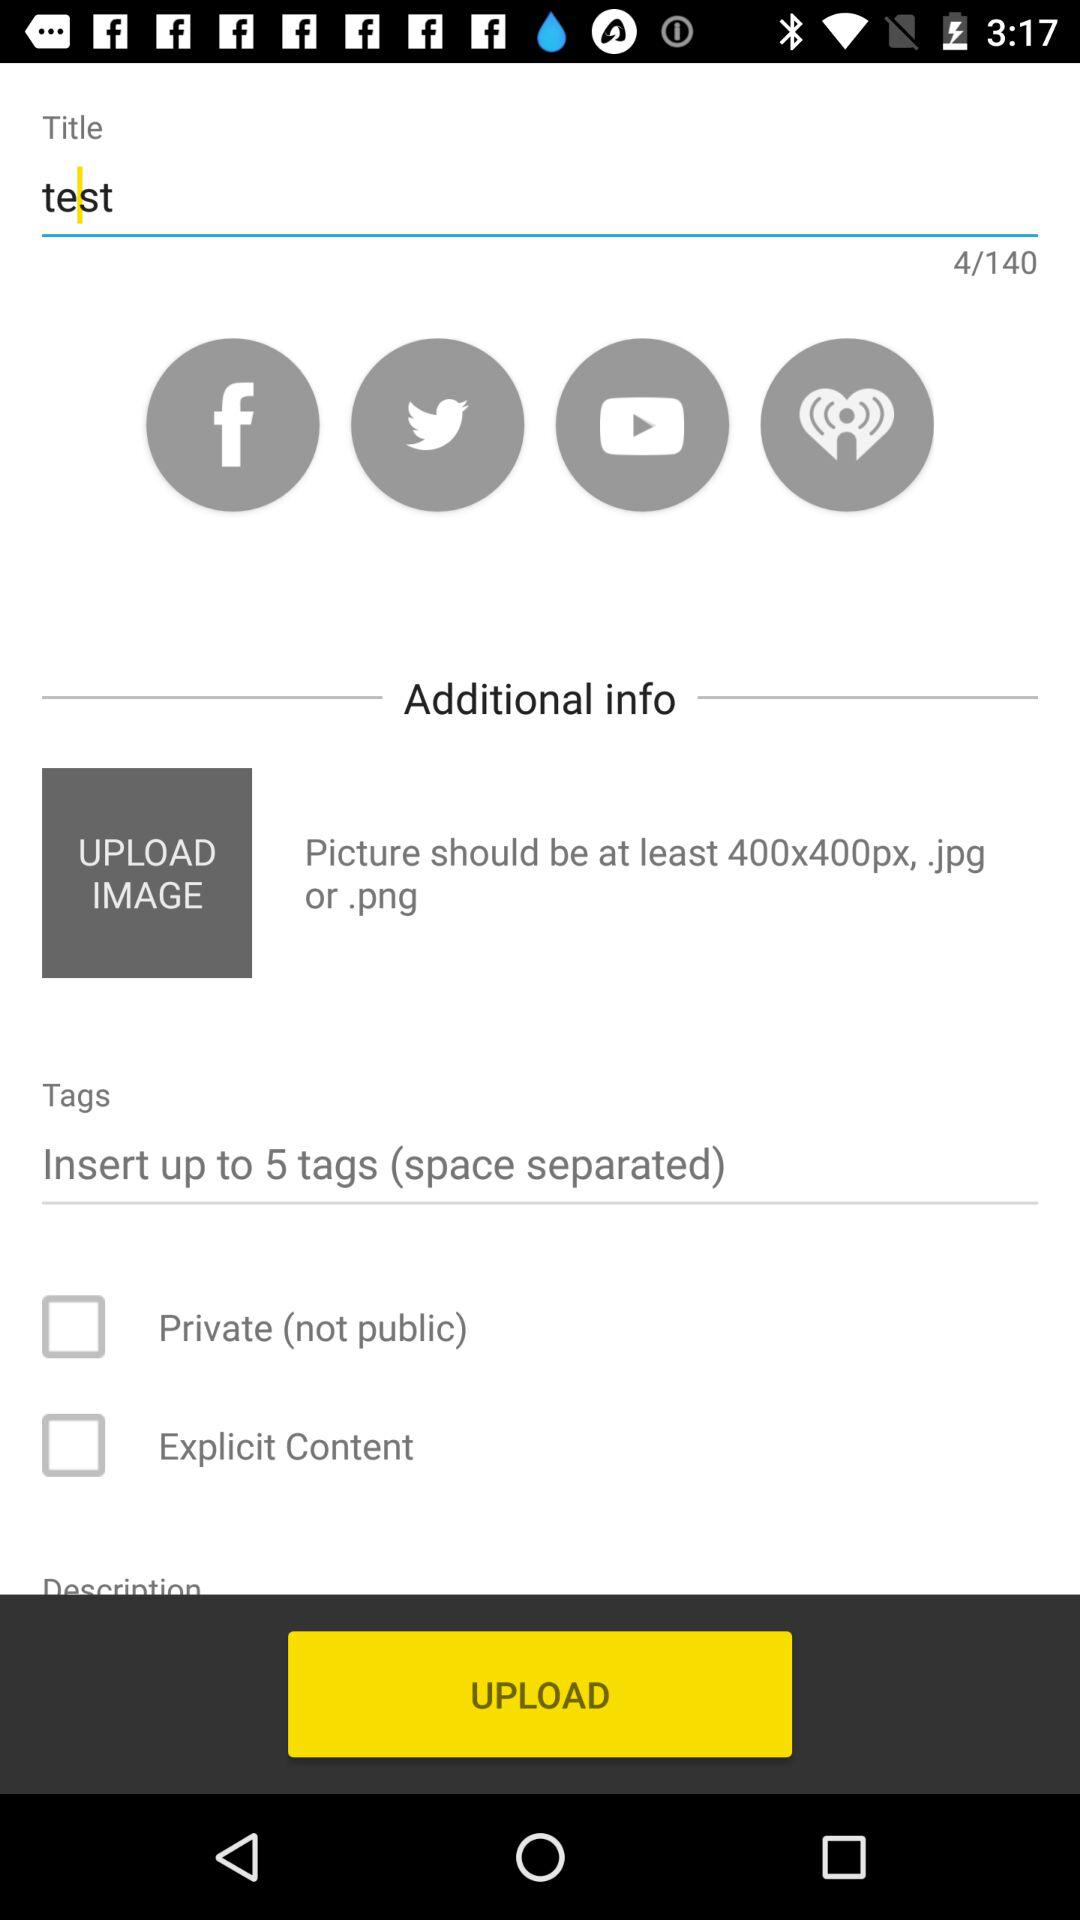What should be the picture size? The picture size should be at least 400 x 400 pixels. 